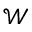Convert formula to latex. <formula><loc_0><loc_0><loc_500><loc_500>\mathcal { W }</formula> 